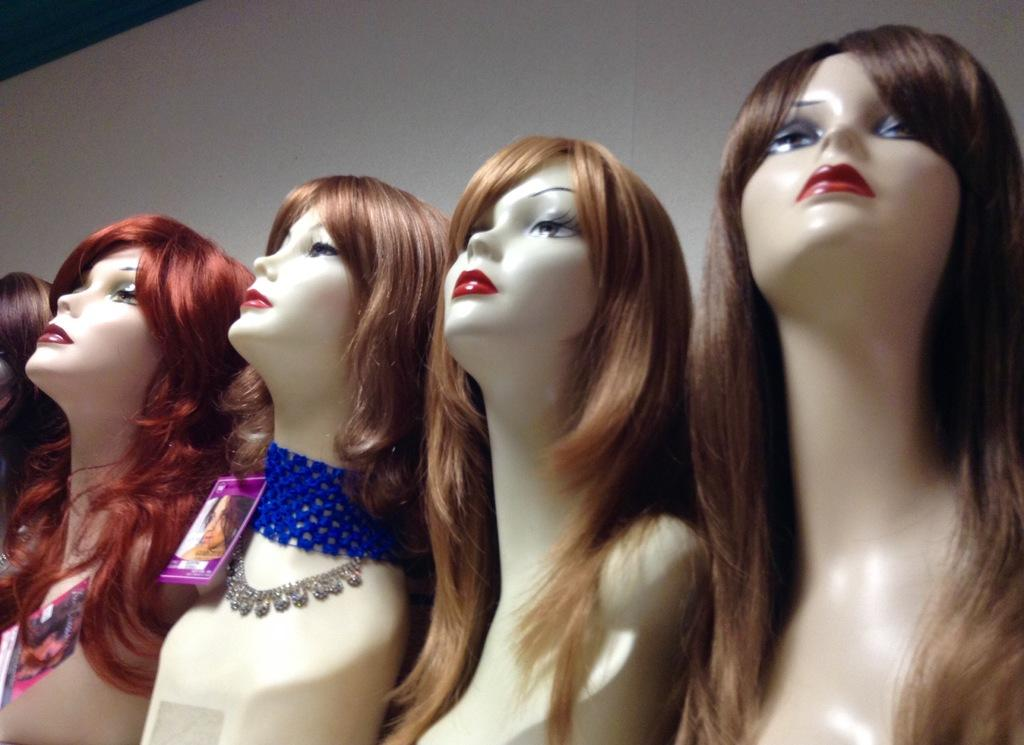What type of figures are present in the image? There are mannequins in the image. What is placed on the mannequins? There is an ornament on the mannequins. What type of fabric is draped over the mannequins? There is blue woolen cloth on the mannequins. Are there any other items visible on the mannequins? Yes, there are other objects visible on the mannequins. What color is the background of the image? The background of the image is white. What is the weight of the son in the image? There is no son present in the image; it features mannequins with ornaments and blue woolen cloth. What type of stove is visible in the image? There is no stove present in the image. 